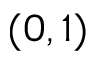<formula> <loc_0><loc_0><loc_500><loc_500>( 0 , 1 )</formula> 